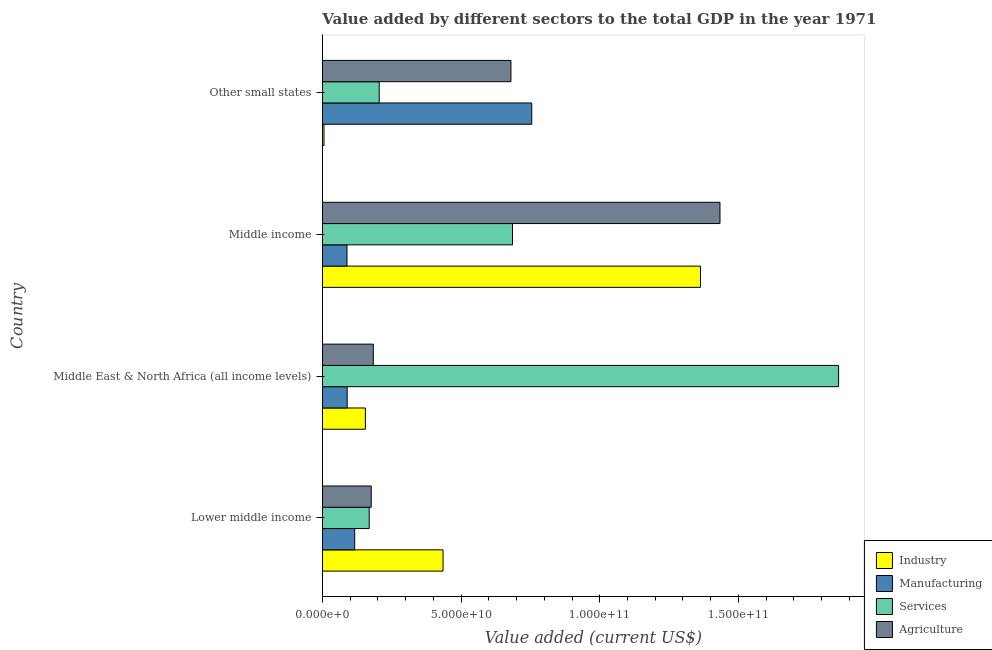Are the number of bars on each tick of the Y-axis equal?
Your answer should be very brief. Yes. How many bars are there on the 4th tick from the top?
Keep it short and to the point. 4. How many bars are there on the 3rd tick from the bottom?
Your answer should be very brief. 4. What is the label of the 4th group of bars from the top?
Your response must be concise. Lower middle income. In how many cases, is the number of bars for a given country not equal to the number of legend labels?
Your answer should be compact. 0. What is the value added by agricultural sector in Lower middle income?
Make the answer very short. 1.76e+1. Across all countries, what is the maximum value added by agricultural sector?
Make the answer very short. 1.43e+11. Across all countries, what is the minimum value added by industrial sector?
Offer a terse response. 5.98e+08. In which country was the value added by services sector maximum?
Offer a very short reply. Middle East & North Africa (all income levels). In which country was the value added by industrial sector minimum?
Provide a succinct answer. Other small states. What is the total value added by services sector in the graph?
Offer a very short reply. 2.92e+11. What is the difference between the value added by agricultural sector in Middle income and that in Other small states?
Ensure brevity in your answer.  7.54e+1. What is the difference between the value added by manufacturing sector in Middle East & North Africa (all income levels) and the value added by agricultural sector in Other small states?
Your answer should be very brief. -5.90e+1. What is the average value added by manufacturing sector per country?
Your response must be concise. 2.62e+1. What is the difference between the value added by manufacturing sector and value added by agricultural sector in Other small states?
Ensure brevity in your answer.  7.50e+09. What is the ratio of the value added by services sector in Middle East & North Africa (all income levels) to that in Middle income?
Ensure brevity in your answer.  2.71. Is the value added by agricultural sector in Middle East & North Africa (all income levels) less than that in Other small states?
Your answer should be very brief. Yes. What is the difference between the highest and the second highest value added by services sector?
Provide a succinct answer. 1.18e+11. What is the difference between the highest and the lowest value added by services sector?
Provide a succinct answer. 1.69e+11. In how many countries, is the value added by services sector greater than the average value added by services sector taken over all countries?
Offer a terse response. 1. Is the sum of the value added by manufacturing sector in Middle East & North Africa (all income levels) and Other small states greater than the maximum value added by agricultural sector across all countries?
Provide a short and direct response. No. Is it the case that in every country, the sum of the value added by services sector and value added by agricultural sector is greater than the sum of value added by manufacturing sector and value added by industrial sector?
Give a very brief answer. No. What does the 3rd bar from the top in Other small states represents?
Give a very brief answer. Manufacturing. What does the 2nd bar from the bottom in Middle income represents?
Make the answer very short. Manufacturing. Is it the case that in every country, the sum of the value added by industrial sector and value added by manufacturing sector is greater than the value added by services sector?
Ensure brevity in your answer.  No. Are all the bars in the graph horizontal?
Your answer should be very brief. Yes. How many countries are there in the graph?
Provide a short and direct response. 4. Does the graph contain any zero values?
Provide a short and direct response. No. Where does the legend appear in the graph?
Keep it short and to the point. Bottom right. How many legend labels are there?
Offer a terse response. 4. What is the title of the graph?
Make the answer very short. Value added by different sectors to the total GDP in the year 1971. Does "Tracking ability" appear as one of the legend labels in the graph?
Make the answer very short. No. What is the label or title of the X-axis?
Keep it short and to the point. Value added (current US$). What is the label or title of the Y-axis?
Provide a short and direct response. Country. What is the Value added (current US$) in Industry in Lower middle income?
Give a very brief answer. 4.35e+1. What is the Value added (current US$) in Manufacturing in Lower middle income?
Offer a very short reply. 1.17e+1. What is the Value added (current US$) in Services in Lower middle income?
Offer a terse response. 1.69e+1. What is the Value added (current US$) of Agriculture in Lower middle income?
Keep it short and to the point. 1.76e+1. What is the Value added (current US$) in Industry in Middle East & North Africa (all income levels)?
Your response must be concise. 1.55e+1. What is the Value added (current US$) in Manufacturing in Middle East & North Africa (all income levels)?
Your answer should be very brief. 8.95e+09. What is the Value added (current US$) of Services in Middle East & North Africa (all income levels)?
Make the answer very short. 1.86e+11. What is the Value added (current US$) in Agriculture in Middle East & North Africa (all income levels)?
Provide a succinct answer. 1.84e+1. What is the Value added (current US$) in Industry in Middle income?
Your response must be concise. 1.36e+11. What is the Value added (current US$) of Manufacturing in Middle income?
Your answer should be very brief. 8.89e+09. What is the Value added (current US$) in Services in Middle income?
Your response must be concise. 6.85e+1. What is the Value added (current US$) of Agriculture in Middle income?
Provide a succinct answer. 1.43e+11. What is the Value added (current US$) in Industry in Other small states?
Provide a short and direct response. 5.98e+08. What is the Value added (current US$) in Manufacturing in Other small states?
Your answer should be very brief. 7.55e+1. What is the Value added (current US$) of Services in Other small states?
Offer a very short reply. 2.05e+1. What is the Value added (current US$) of Agriculture in Other small states?
Your response must be concise. 6.80e+1. Across all countries, what is the maximum Value added (current US$) of Industry?
Your response must be concise. 1.36e+11. Across all countries, what is the maximum Value added (current US$) of Manufacturing?
Ensure brevity in your answer.  7.55e+1. Across all countries, what is the maximum Value added (current US$) in Services?
Give a very brief answer. 1.86e+11. Across all countries, what is the maximum Value added (current US$) in Agriculture?
Your answer should be compact. 1.43e+11. Across all countries, what is the minimum Value added (current US$) in Industry?
Your answer should be very brief. 5.98e+08. Across all countries, what is the minimum Value added (current US$) of Manufacturing?
Offer a very short reply. 8.89e+09. Across all countries, what is the minimum Value added (current US$) of Services?
Provide a succinct answer. 1.69e+1. Across all countries, what is the minimum Value added (current US$) of Agriculture?
Give a very brief answer. 1.76e+1. What is the total Value added (current US$) in Industry in the graph?
Offer a terse response. 1.96e+11. What is the total Value added (current US$) in Manufacturing in the graph?
Your answer should be very brief. 1.05e+11. What is the total Value added (current US$) in Services in the graph?
Offer a terse response. 2.92e+11. What is the total Value added (current US$) of Agriculture in the graph?
Your answer should be compact. 2.47e+11. What is the difference between the Value added (current US$) in Industry in Lower middle income and that in Middle East & North Africa (all income levels)?
Offer a terse response. 2.80e+1. What is the difference between the Value added (current US$) in Manufacturing in Lower middle income and that in Middle East & North Africa (all income levels)?
Offer a terse response. 2.72e+09. What is the difference between the Value added (current US$) in Services in Lower middle income and that in Middle East & North Africa (all income levels)?
Provide a succinct answer. -1.69e+11. What is the difference between the Value added (current US$) of Agriculture in Lower middle income and that in Middle East & North Africa (all income levels)?
Offer a very short reply. -7.43e+08. What is the difference between the Value added (current US$) of Industry in Lower middle income and that in Middle income?
Your answer should be very brief. -9.28e+1. What is the difference between the Value added (current US$) in Manufacturing in Lower middle income and that in Middle income?
Your response must be concise. 2.79e+09. What is the difference between the Value added (current US$) in Services in Lower middle income and that in Middle income?
Offer a very short reply. -5.17e+1. What is the difference between the Value added (current US$) of Agriculture in Lower middle income and that in Middle income?
Ensure brevity in your answer.  -1.26e+11. What is the difference between the Value added (current US$) of Industry in Lower middle income and that in Other small states?
Offer a terse response. 4.29e+1. What is the difference between the Value added (current US$) of Manufacturing in Lower middle income and that in Other small states?
Ensure brevity in your answer.  -6.38e+1. What is the difference between the Value added (current US$) in Services in Lower middle income and that in Other small states?
Give a very brief answer. -3.61e+09. What is the difference between the Value added (current US$) of Agriculture in Lower middle income and that in Other small states?
Your answer should be very brief. -5.03e+1. What is the difference between the Value added (current US$) of Industry in Middle East & North Africa (all income levels) and that in Middle income?
Offer a very short reply. -1.21e+11. What is the difference between the Value added (current US$) in Manufacturing in Middle East & North Africa (all income levels) and that in Middle income?
Provide a short and direct response. 6.40e+07. What is the difference between the Value added (current US$) of Services in Middle East & North Africa (all income levels) and that in Middle income?
Ensure brevity in your answer.  1.18e+11. What is the difference between the Value added (current US$) in Agriculture in Middle East & North Africa (all income levels) and that in Middle income?
Offer a terse response. -1.25e+11. What is the difference between the Value added (current US$) of Industry in Middle East & North Africa (all income levels) and that in Other small states?
Your answer should be very brief. 1.49e+1. What is the difference between the Value added (current US$) of Manufacturing in Middle East & North Africa (all income levels) and that in Other small states?
Your response must be concise. -6.65e+1. What is the difference between the Value added (current US$) of Services in Middle East & North Africa (all income levels) and that in Other small states?
Offer a terse response. 1.66e+11. What is the difference between the Value added (current US$) of Agriculture in Middle East & North Africa (all income levels) and that in Other small states?
Your answer should be very brief. -4.96e+1. What is the difference between the Value added (current US$) in Industry in Middle income and that in Other small states?
Your answer should be compact. 1.36e+11. What is the difference between the Value added (current US$) of Manufacturing in Middle income and that in Other small states?
Provide a short and direct response. -6.66e+1. What is the difference between the Value added (current US$) of Services in Middle income and that in Other small states?
Your answer should be compact. 4.80e+1. What is the difference between the Value added (current US$) in Agriculture in Middle income and that in Other small states?
Provide a short and direct response. 7.54e+1. What is the difference between the Value added (current US$) in Industry in Lower middle income and the Value added (current US$) in Manufacturing in Middle East & North Africa (all income levels)?
Your answer should be compact. 3.46e+1. What is the difference between the Value added (current US$) of Industry in Lower middle income and the Value added (current US$) of Services in Middle East & North Africa (all income levels)?
Offer a terse response. -1.43e+11. What is the difference between the Value added (current US$) in Industry in Lower middle income and the Value added (current US$) in Agriculture in Middle East & North Africa (all income levels)?
Keep it short and to the point. 2.51e+1. What is the difference between the Value added (current US$) in Manufacturing in Lower middle income and the Value added (current US$) in Services in Middle East & North Africa (all income levels)?
Your answer should be very brief. -1.74e+11. What is the difference between the Value added (current US$) of Manufacturing in Lower middle income and the Value added (current US$) of Agriculture in Middle East & North Africa (all income levels)?
Keep it short and to the point. -6.70e+09. What is the difference between the Value added (current US$) of Services in Lower middle income and the Value added (current US$) of Agriculture in Middle East & North Africa (all income levels)?
Ensure brevity in your answer.  -1.48e+09. What is the difference between the Value added (current US$) in Industry in Lower middle income and the Value added (current US$) in Manufacturing in Middle income?
Keep it short and to the point. 3.46e+1. What is the difference between the Value added (current US$) in Industry in Lower middle income and the Value added (current US$) in Services in Middle income?
Your answer should be compact. -2.50e+1. What is the difference between the Value added (current US$) of Industry in Lower middle income and the Value added (current US$) of Agriculture in Middle income?
Give a very brief answer. -9.98e+1. What is the difference between the Value added (current US$) in Manufacturing in Lower middle income and the Value added (current US$) in Services in Middle income?
Offer a terse response. -5.69e+1. What is the difference between the Value added (current US$) in Manufacturing in Lower middle income and the Value added (current US$) in Agriculture in Middle income?
Provide a short and direct response. -1.32e+11. What is the difference between the Value added (current US$) of Services in Lower middle income and the Value added (current US$) of Agriculture in Middle income?
Your response must be concise. -1.26e+11. What is the difference between the Value added (current US$) of Industry in Lower middle income and the Value added (current US$) of Manufacturing in Other small states?
Offer a very short reply. -3.20e+1. What is the difference between the Value added (current US$) in Industry in Lower middle income and the Value added (current US$) in Services in Other small states?
Keep it short and to the point. 2.30e+1. What is the difference between the Value added (current US$) in Industry in Lower middle income and the Value added (current US$) in Agriculture in Other small states?
Offer a terse response. -2.45e+1. What is the difference between the Value added (current US$) of Manufacturing in Lower middle income and the Value added (current US$) of Services in Other small states?
Give a very brief answer. -8.82e+09. What is the difference between the Value added (current US$) of Manufacturing in Lower middle income and the Value added (current US$) of Agriculture in Other small states?
Provide a succinct answer. -5.63e+1. What is the difference between the Value added (current US$) of Services in Lower middle income and the Value added (current US$) of Agriculture in Other small states?
Ensure brevity in your answer.  -5.11e+1. What is the difference between the Value added (current US$) in Industry in Middle East & North Africa (all income levels) and the Value added (current US$) in Manufacturing in Middle income?
Provide a succinct answer. 6.63e+09. What is the difference between the Value added (current US$) in Industry in Middle East & North Africa (all income levels) and the Value added (current US$) in Services in Middle income?
Keep it short and to the point. -5.30e+1. What is the difference between the Value added (current US$) in Industry in Middle East & North Africa (all income levels) and the Value added (current US$) in Agriculture in Middle income?
Your answer should be very brief. -1.28e+11. What is the difference between the Value added (current US$) of Manufacturing in Middle East & North Africa (all income levels) and the Value added (current US$) of Services in Middle income?
Make the answer very short. -5.96e+1. What is the difference between the Value added (current US$) in Manufacturing in Middle East & North Africa (all income levels) and the Value added (current US$) in Agriculture in Middle income?
Offer a very short reply. -1.34e+11. What is the difference between the Value added (current US$) of Services in Middle East & North Africa (all income levels) and the Value added (current US$) of Agriculture in Middle income?
Make the answer very short. 4.28e+1. What is the difference between the Value added (current US$) in Industry in Middle East & North Africa (all income levels) and the Value added (current US$) in Manufacturing in Other small states?
Offer a terse response. -6.00e+1. What is the difference between the Value added (current US$) of Industry in Middle East & North Africa (all income levels) and the Value added (current US$) of Services in Other small states?
Provide a short and direct response. -4.98e+09. What is the difference between the Value added (current US$) in Industry in Middle East & North Africa (all income levels) and the Value added (current US$) in Agriculture in Other small states?
Give a very brief answer. -5.25e+1. What is the difference between the Value added (current US$) in Manufacturing in Middle East & North Africa (all income levels) and the Value added (current US$) in Services in Other small states?
Make the answer very short. -1.15e+1. What is the difference between the Value added (current US$) of Manufacturing in Middle East & North Africa (all income levels) and the Value added (current US$) of Agriculture in Other small states?
Your answer should be compact. -5.90e+1. What is the difference between the Value added (current US$) in Services in Middle East & North Africa (all income levels) and the Value added (current US$) in Agriculture in Other small states?
Keep it short and to the point. 1.18e+11. What is the difference between the Value added (current US$) in Industry in Middle income and the Value added (current US$) in Manufacturing in Other small states?
Offer a very short reply. 6.08e+1. What is the difference between the Value added (current US$) of Industry in Middle income and the Value added (current US$) of Services in Other small states?
Your response must be concise. 1.16e+11. What is the difference between the Value added (current US$) of Industry in Middle income and the Value added (current US$) of Agriculture in Other small states?
Give a very brief answer. 6.83e+1. What is the difference between the Value added (current US$) of Manufacturing in Middle income and the Value added (current US$) of Services in Other small states?
Provide a short and direct response. -1.16e+1. What is the difference between the Value added (current US$) of Manufacturing in Middle income and the Value added (current US$) of Agriculture in Other small states?
Give a very brief answer. -5.91e+1. What is the difference between the Value added (current US$) in Services in Middle income and the Value added (current US$) in Agriculture in Other small states?
Keep it short and to the point. 5.71e+08. What is the average Value added (current US$) in Industry per country?
Provide a succinct answer. 4.90e+1. What is the average Value added (current US$) of Manufacturing per country?
Make the answer very short. 2.62e+1. What is the average Value added (current US$) in Services per country?
Make the answer very short. 7.30e+1. What is the average Value added (current US$) of Agriculture per country?
Ensure brevity in your answer.  6.18e+1. What is the difference between the Value added (current US$) of Industry and Value added (current US$) of Manufacturing in Lower middle income?
Provide a short and direct response. 3.18e+1. What is the difference between the Value added (current US$) of Industry and Value added (current US$) of Services in Lower middle income?
Provide a succinct answer. 2.66e+1. What is the difference between the Value added (current US$) of Industry and Value added (current US$) of Agriculture in Lower middle income?
Your answer should be very brief. 2.59e+1. What is the difference between the Value added (current US$) in Manufacturing and Value added (current US$) in Services in Lower middle income?
Give a very brief answer. -5.22e+09. What is the difference between the Value added (current US$) of Manufacturing and Value added (current US$) of Agriculture in Lower middle income?
Your answer should be very brief. -5.95e+09. What is the difference between the Value added (current US$) in Services and Value added (current US$) in Agriculture in Lower middle income?
Keep it short and to the point. -7.34e+08. What is the difference between the Value added (current US$) in Industry and Value added (current US$) in Manufacturing in Middle East & North Africa (all income levels)?
Give a very brief answer. 6.57e+09. What is the difference between the Value added (current US$) in Industry and Value added (current US$) in Services in Middle East & North Africa (all income levels)?
Your response must be concise. -1.71e+11. What is the difference between the Value added (current US$) of Industry and Value added (current US$) of Agriculture in Middle East & North Africa (all income levels)?
Your response must be concise. -2.85e+09. What is the difference between the Value added (current US$) in Manufacturing and Value added (current US$) in Services in Middle East & North Africa (all income levels)?
Ensure brevity in your answer.  -1.77e+11. What is the difference between the Value added (current US$) of Manufacturing and Value added (current US$) of Agriculture in Middle East & North Africa (all income levels)?
Make the answer very short. -9.42e+09. What is the difference between the Value added (current US$) of Services and Value added (current US$) of Agriculture in Middle East & North Africa (all income levels)?
Your answer should be compact. 1.68e+11. What is the difference between the Value added (current US$) of Industry and Value added (current US$) of Manufacturing in Middle income?
Your answer should be very brief. 1.27e+11. What is the difference between the Value added (current US$) in Industry and Value added (current US$) in Services in Middle income?
Provide a short and direct response. 6.78e+1. What is the difference between the Value added (current US$) of Industry and Value added (current US$) of Agriculture in Middle income?
Make the answer very short. -7.03e+09. What is the difference between the Value added (current US$) in Manufacturing and Value added (current US$) in Services in Middle income?
Your answer should be very brief. -5.97e+1. What is the difference between the Value added (current US$) in Manufacturing and Value added (current US$) in Agriculture in Middle income?
Your response must be concise. -1.34e+11. What is the difference between the Value added (current US$) of Services and Value added (current US$) of Agriculture in Middle income?
Offer a very short reply. -7.48e+1. What is the difference between the Value added (current US$) of Industry and Value added (current US$) of Manufacturing in Other small states?
Your answer should be very brief. -7.49e+1. What is the difference between the Value added (current US$) in Industry and Value added (current US$) in Services in Other small states?
Give a very brief answer. -1.99e+1. What is the difference between the Value added (current US$) in Industry and Value added (current US$) in Agriculture in Other small states?
Make the answer very short. -6.74e+1. What is the difference between the Value added (current US$) in Manufacturing and Value added (current US$) in Services in Other small states?
Ensure brevity in your answer.  5.50e+1. What is the difference between the Value added (current US$) of Manufacturing and Value added (current US$) of Agriculture in Other small states?
Give a very brief answer. 7.50e+09. What is the difference between the Value added (current US$) of Services and Value added (current US$) of Agriculture in Other small states?
Make the answer very short. -4.75e+1. What is the ratio of the Value added (current US$) in Industry in Lower middle income to that in Middle East & North Africa (all income levels)?
Your response must be concise. 2.8. What is the ratio of the Value added (current US$) of Manufacturing in Lower middle income to that in Middle East & North Africa (all income levels)?
Provide a short and direct response. 1.3. What is the ratio of the Value added (current US$) in Services in Lower middle income to that in Middle East & North Africa (all income levels)?
Offer a very short reply. 0.09. What is the ratio of the Value added (current US$) of Agriculture in Lower middle income to that in Middle East & North Africa (all income levels)?
Offer a very short reply. 0.96. What is the ratio of the Value added (current US$) in Industry in Lower middle income to that in Middle income?
Offer a very short reply. 0.32. What is the ratio of the Value added (current US$) of Manufacturing in Lower middle income to that in Middle income?
Give a very brief answer. 1.31. What is the ratio of the Value added (current US$) in Services in Lower middle income to that in Middle income?
Your answer should be compact. 0.25. What is the ratio of the Value added (current US$) of Agriculture in Lower middle income to that in Middle income?
Your answer should be very brief. 0.12. What is the ratio of the Value added (current US$) in Industry in Lower middle income to that in Other small states?
Ensure brevity in your answer.  72.75. What is the ratio of the Value added (current US$) in Manufacturing in Lower middle income to that in Other small states?
Your answer should be compact. 0.15. What is the ratio of the Value added (current US$) in Services in Lower middle income to that in Other small states?
Make the answer very short. 0.82. What is the ratio of the Value added (current US$) of Agriculture in Lower middle income to that in Other small states?
Make the answer very short. 0.26. What is the ratio of the Value added (current US$) in Industry in Middle East & North Africa (all income levels) to that in Middle income?
Offer a terse response. 0.11. What is the ratio of the Value added (current US$) in Services in Middle East & North Africa (all income levels) to that in Middle income?
Make the answer very short. 2.71. What is the ratio of the Value added (current US$) of Agriculture in Middle East & North Africa (all income levels) to that in Middle income?
Offer a very short reply. 0.13. What is the ratio of the Value added (current US$) in Industry in Middle East & North Africa (all income levels) to that in Other small states?
Your answer should be compact. 25.95. What is the ratio of the Value added (current US$) of Manufacturing in Middle East & North Africa (all income levels) to that in Other small states?
Make the answer very short. 0.12. What is the ratio of the Value added (current US$) of Services in Middle East & North Africa (all income levels) to that in Other small states?
Your response must be concise. 9.08. What is the ratio of the Value added (current US$) in Agriculture in Middle East & North Africa (all income levels) to that in Other small states?
Provide a short and direct response. 0.27. What is the ratio of the Value added (current US$) in Industry in Middle income to that in Other small states?
Your answer should be compact. 227.91. What is the ratio of the Value added (current US$) in Manufacturing in Middle income to that in Other small states?
Your answer should be very brief. 0.12. What is the ratio of the Value added (current US$) of Services in Middle income to that in Other small states?
Your answer should be very brief. 3.34. What is the ratio of the Value added (current US$) of Agriculture in Middle income to that in Other small states?
Offer a terse response. 2.11. What is the difference between the highest and the second highest Value added (current US$) of Industry?
Your answer should be very brief. 9.28e+1. What is the difference between the highest and the second highest Value added (current US$) of Manufacturing?
Your answer should be very brief. 6.38e+1. What is the difference between the highest and the second highest Value added (current US$) of Services?
Keep it short and to the point. 1.18e+11. What is the difference between the highest and the second highest Value added (current US$) in Agriculture?
Provide a succinct answer. 7.54e+1. What is the difference between the highest and the lowest Value added (current US$) in Industry?
Make the answer very short. 1.36e+11. What is the difference between the highest and the lowest Value added (current US$) in Manufacturing?
Your response must be concise. 6.66e+1. What is the difference between the highest and the lowest Value added (current US$) of Services?
Provide a succinct answer. 1.69e+11. What is the difference between the highest and the lowest Value added (current US$) of Agriculture?
Your response must be concise. 1.26e+11. 